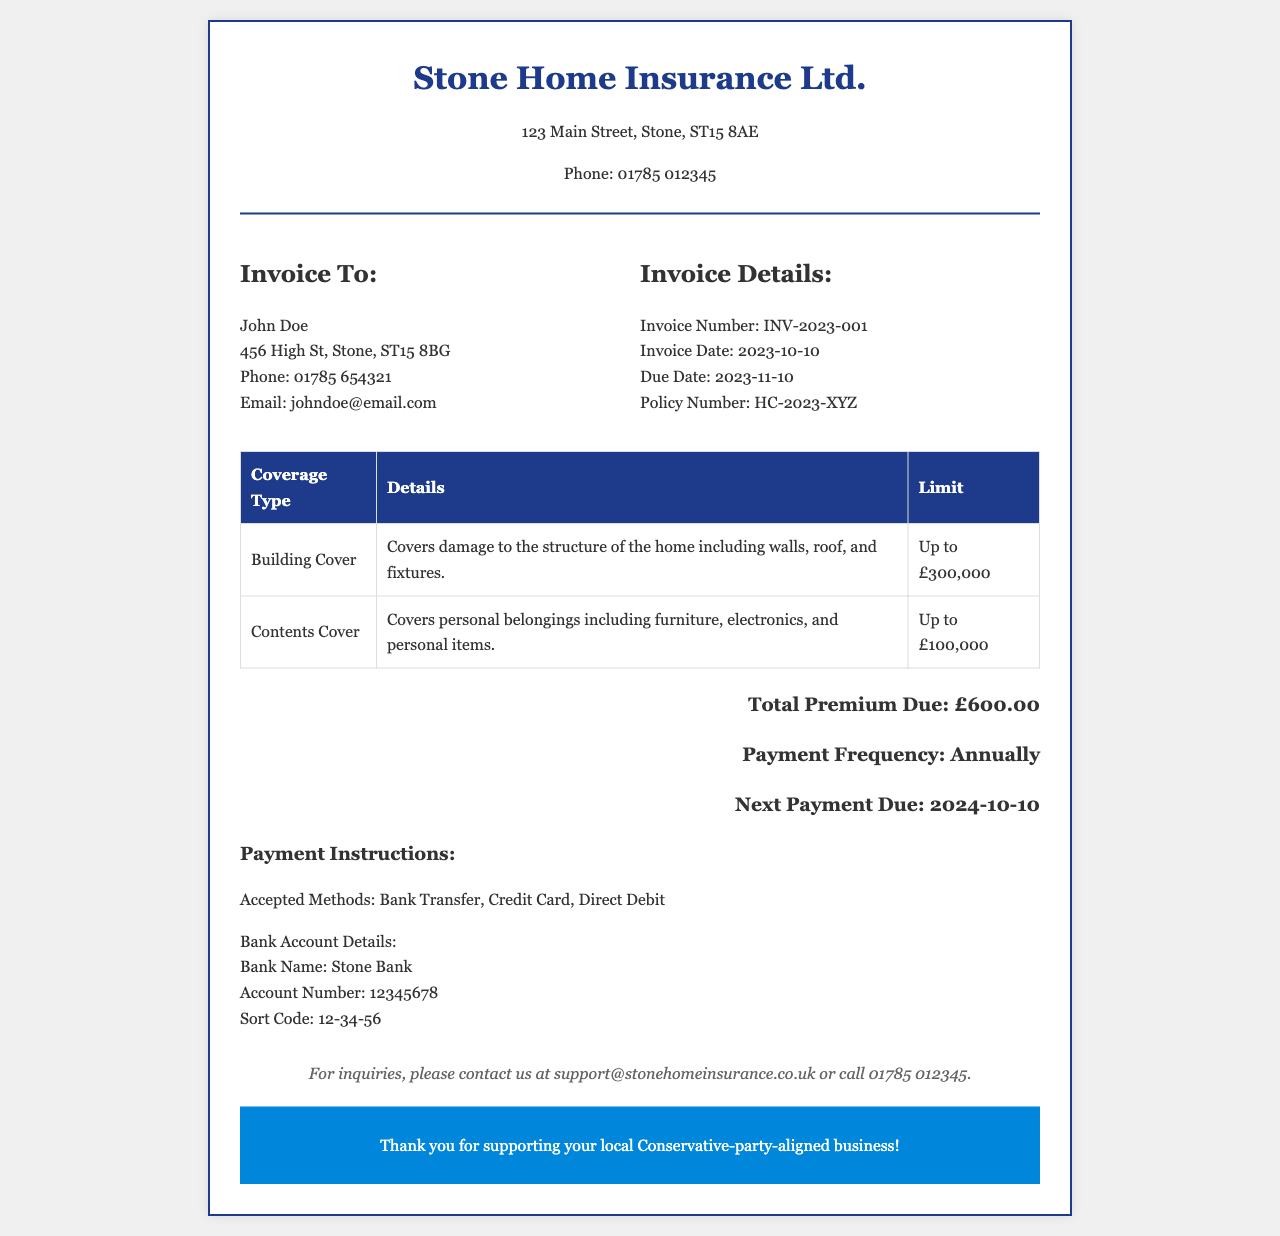What is the invoice number? The invoice number is a unique identifier for this document, found in the invoice details section.
Answer: INV-2023-001 What is the total premium due? The total premium due is the amount payable for the insurance coverage, mentioned in the total section.
Answer: £600.00 What is the due date for the payment? The due date specifies when the payment must be made and is listed under invoice details.
Answer: 2023-11-10 What is the building cover limit? The building cover limit indicates the maximum amount the insurance will cover for building damage, presented in the coverage table.
Answer: Up to £300,000 How often is the payment made? The payment frequency describes how often the premium payment is due and is stated in the total section.
Answer: Annually What type of insurance is this invoice for? The type of insurance refers to the specific protection coverage that is being billed, as indicated by the document's title.
Answer: Home insurance What are the accepted payment methods? Accepted payment methods outline the different ways the payment can be made, which can be found in the payment instructions.
Answer: Bank Transfer, Credit Card, Direct Debit Who is the invoice addressed to? The name of the person to whom the invoice is issued is listed under the invoice to section.
Answer: John Doe What is the policy number? The policy number is a unique identifier for the insurance policy being referenced in the invoice, found in the invoice details.
Answer: HC-2023-XYZ 